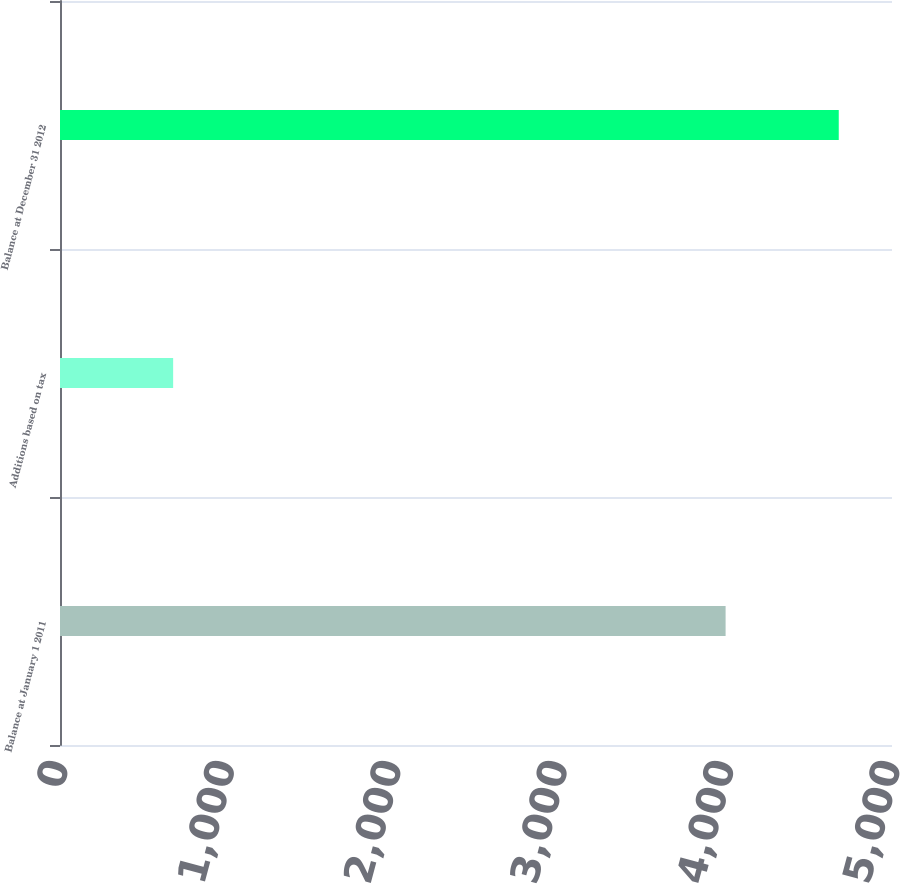<chart> <loc_0><loc_0><loc_500><loc_500><bar_chart><fcel>Balance at January 1 2011<fcel>Additions based on tax<fcel>Balance at December 31 2012<nl><fcel>4000<fcel>680<fcel>4680<nl></chart> 